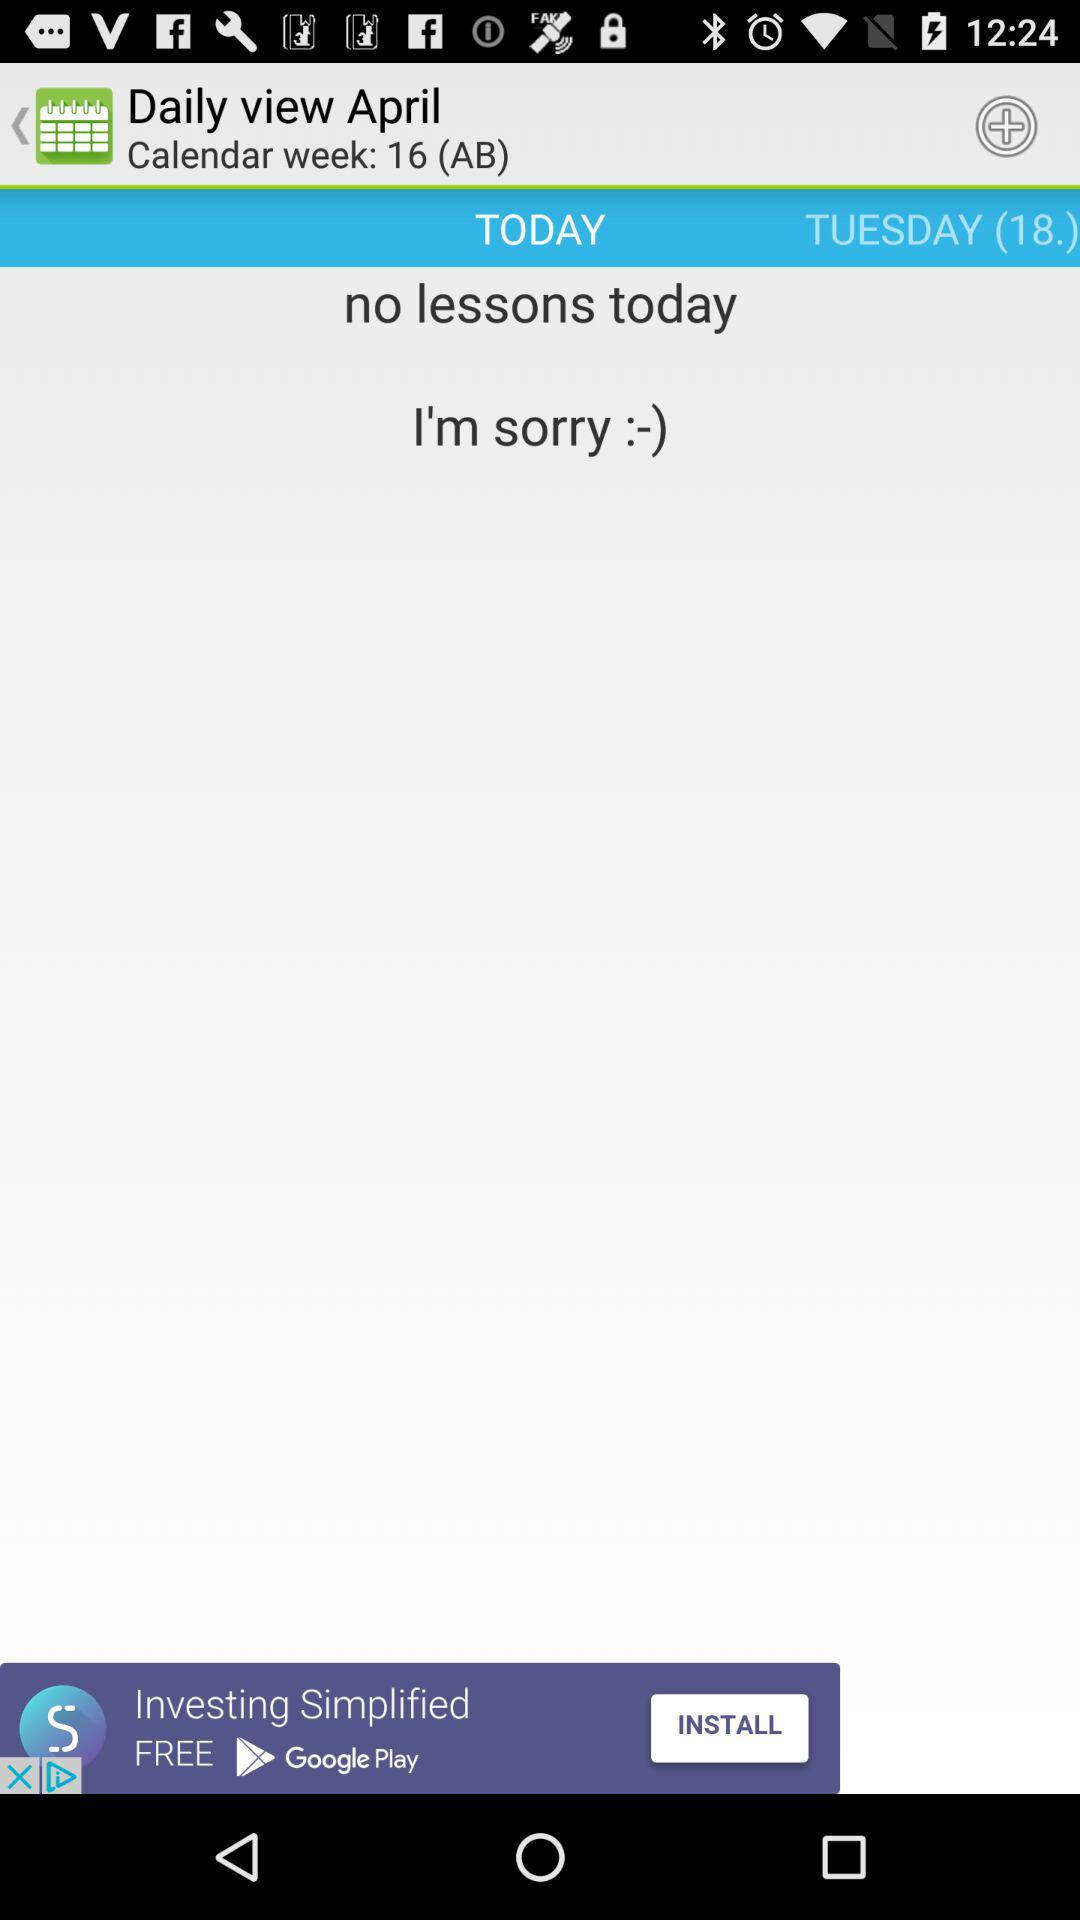Are there any lessons today? There are no lessons today. 